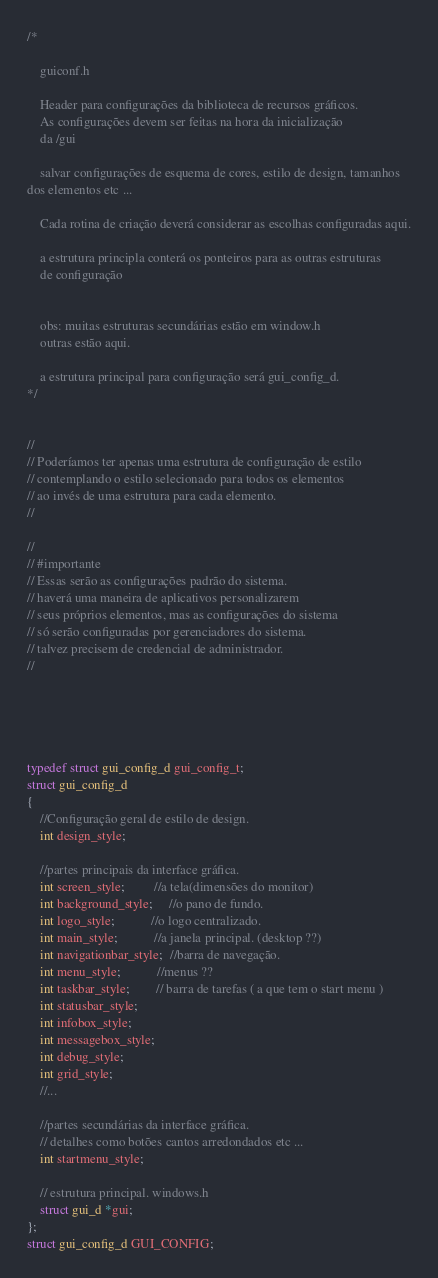<code> <loc_0><loc_0><loc_500><loc_500><_C_>
/*

    guiconf.h
	
	Header para configurações da biblioteca de recursos gráficos.
	As configurações devem ser feitas na hora da inicialização 
	da /gui 

    salvar configurações de esquema de cores, estilo de design, tamanhos 
dos elementos etc ...

    Cada rotina de criação deverá considerar as escolhas configuradas aqui.
	
    a estrutura principla conterá os ponteiros para as outras estruturas 
    de configuração	
	
	
	obs: muitas estruturas secundárias estão em window.h 
	outras estão aqui.
	
	a estrutura principal para configuração será gui_config_d.
*/


//
// Poderíamos ter apenas uma estrutura de configuração de estilo 
// contemplando o estilo selecionado para todos os elementos 
// ao invés de uma estrutura para cada elemento.
//

//
// #importante
// Essas serão as configurações padrão do sistema.
// haverá uma maneira de aplicativos personalizarem 
// seus próprios elementos, mas as configurações do sistema 
// só serão configuradas por gerenciadores do sistema.
// talvez precisem de credencial de administrador.
//





typedef struct gui_config_d gui_config_t;
struct gui_config_d
{
	//Configuração geral de estilo de design.
    int design_style;	
	
	//partes principais da interface gráfica.
	int screen_style;         //a tela(dimensões do monitor)
	int background_style;     //o pano de fundo.
	int logo_style;           //o logo centralizado.
	int main_style;           //a janela principal. (desktop ??)
	int navigationbar_style;  //barra de navegação.
	int menu_style;           //menus ?? 
	int taskbar_style;        // barra de tarefas ( a que tem o start menu ) 
	int statusbar_style;	
	int infobox_style;
	int messagebox_style;
	int debug_style;
	int grid_style;
    //...
	
	//partes secundárias da interface gráfica.
    // detalhes como botões cantos arredondados etc ...      
    int startmenu_style;
	  
	// estrutura principal. windows.h
    struct gui_d *gui;	
};
struct gui_config_d GUI_CONFIG;

</code> 